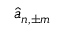Convert formula to latex. <formula><loc_0><loc_0><loc_500><loc_500>\hat { a } _ { n , \pm m }</formula> 